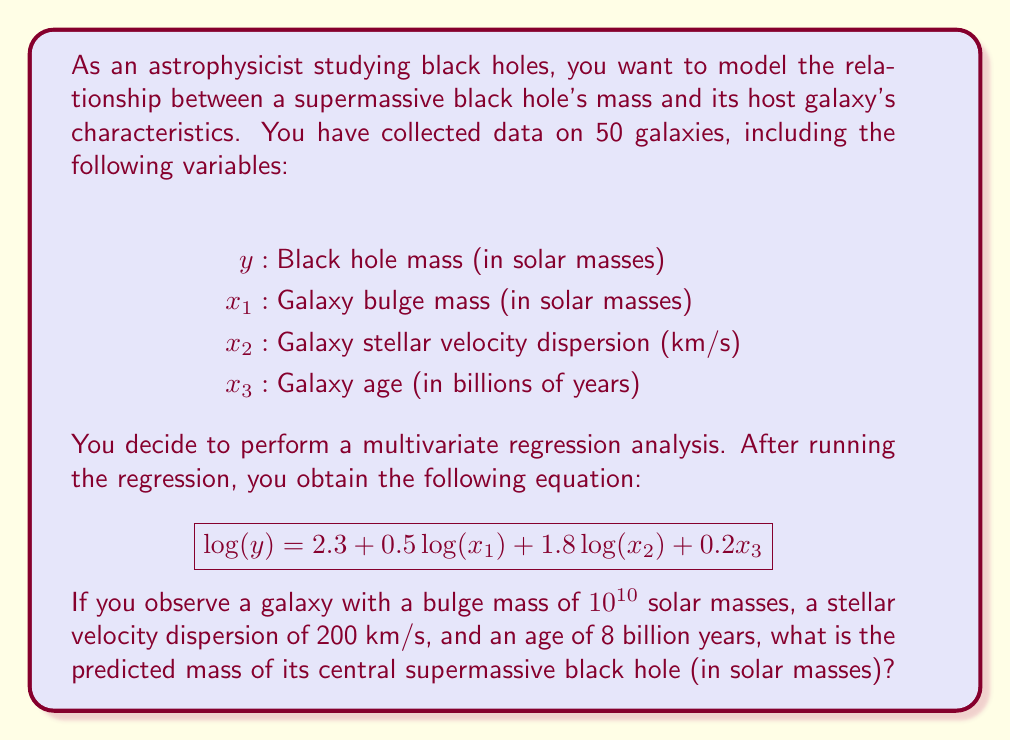Show me your answer to this math problem. To solve this problem, we'll follow these steps:

1) We have the regression equation:
   $$\log(y) = 2.3 + 0.5\log(x_1) + 1.8\log(x_2) + 0.2x_3$$

2) We need to substitute the given values:
   $x_1 = 10^{10}$ solar masses
   $x_2 = 200$ km/s
   $x_3 = 8$ billion years

3) Let's substitute these values into the equation:
   $$\log(y) = 2.3 + 0.5\log(10^{10}) + 1.8\log(200) + 0.2(8)$$

4) Simplify:
   $\log(10^{10}) = 10$
   $\log(200) \approx 2.3010$ (using a calculator or log table)

   $$\log(y) = 2.3 + 0.5(10) + 1.8(2.3010) + 0.2(8)$$

5) Calculate:
   $$\log(y) = 2.3 + 5 + 4.1418 + 1.6 = 13.0418$$

6) To find $y$, we need to take the antilog (10 to the power) of both sides:
   $$y = 10^{13.0418}$$

7) Calculate the final value:
   $$y \approx 1.1 \times 10^{13}$$ solar masses
Answer: The predicted mass of the central supermassive black hole is approximately $1.1 \times 10^{13}$ solar masses. 